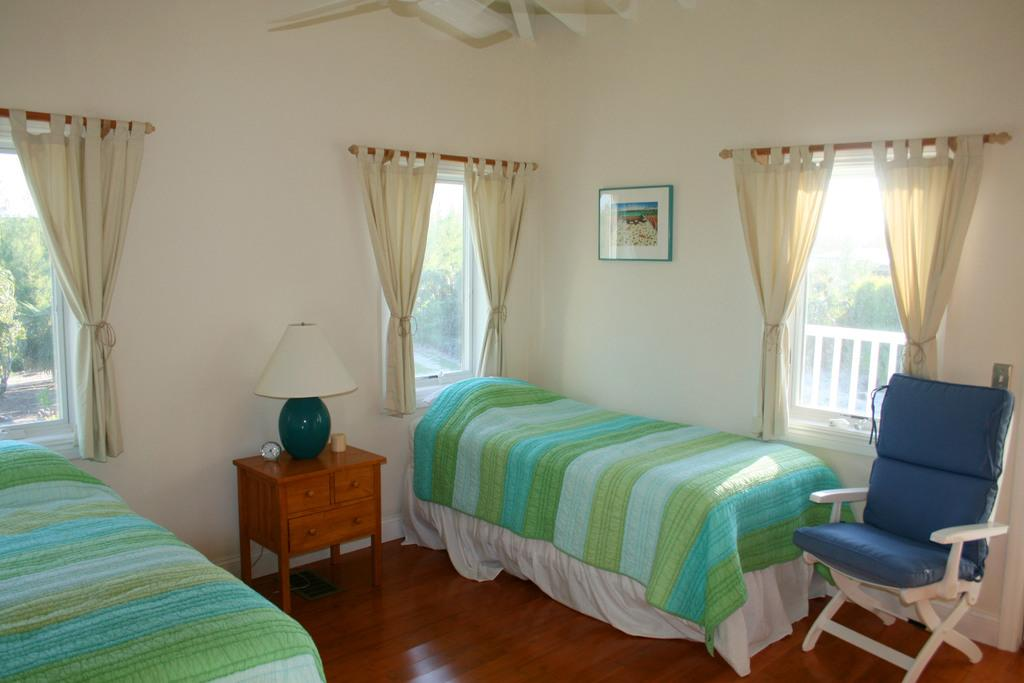What type of furniture is in the image? There is a bedchair in the image. What can be seen on the windows in the image? The windows have curtains in the image. What is present on the wall in the image? There is a frame in the image. What is the purpose of the lamp in the image? The lamp provides light in the image. What time-related object is in the image? There is a clock in the image. What is the background of the image? There is a wall in the image. What can be seen outside the window in the image? Trees are visible through the window in the image. How many babies are present in the image? There are no babies present in the image. What type of picture is hanging on the wall in the image? The provided facts do not mention a picture hanging on the wall in the image. 